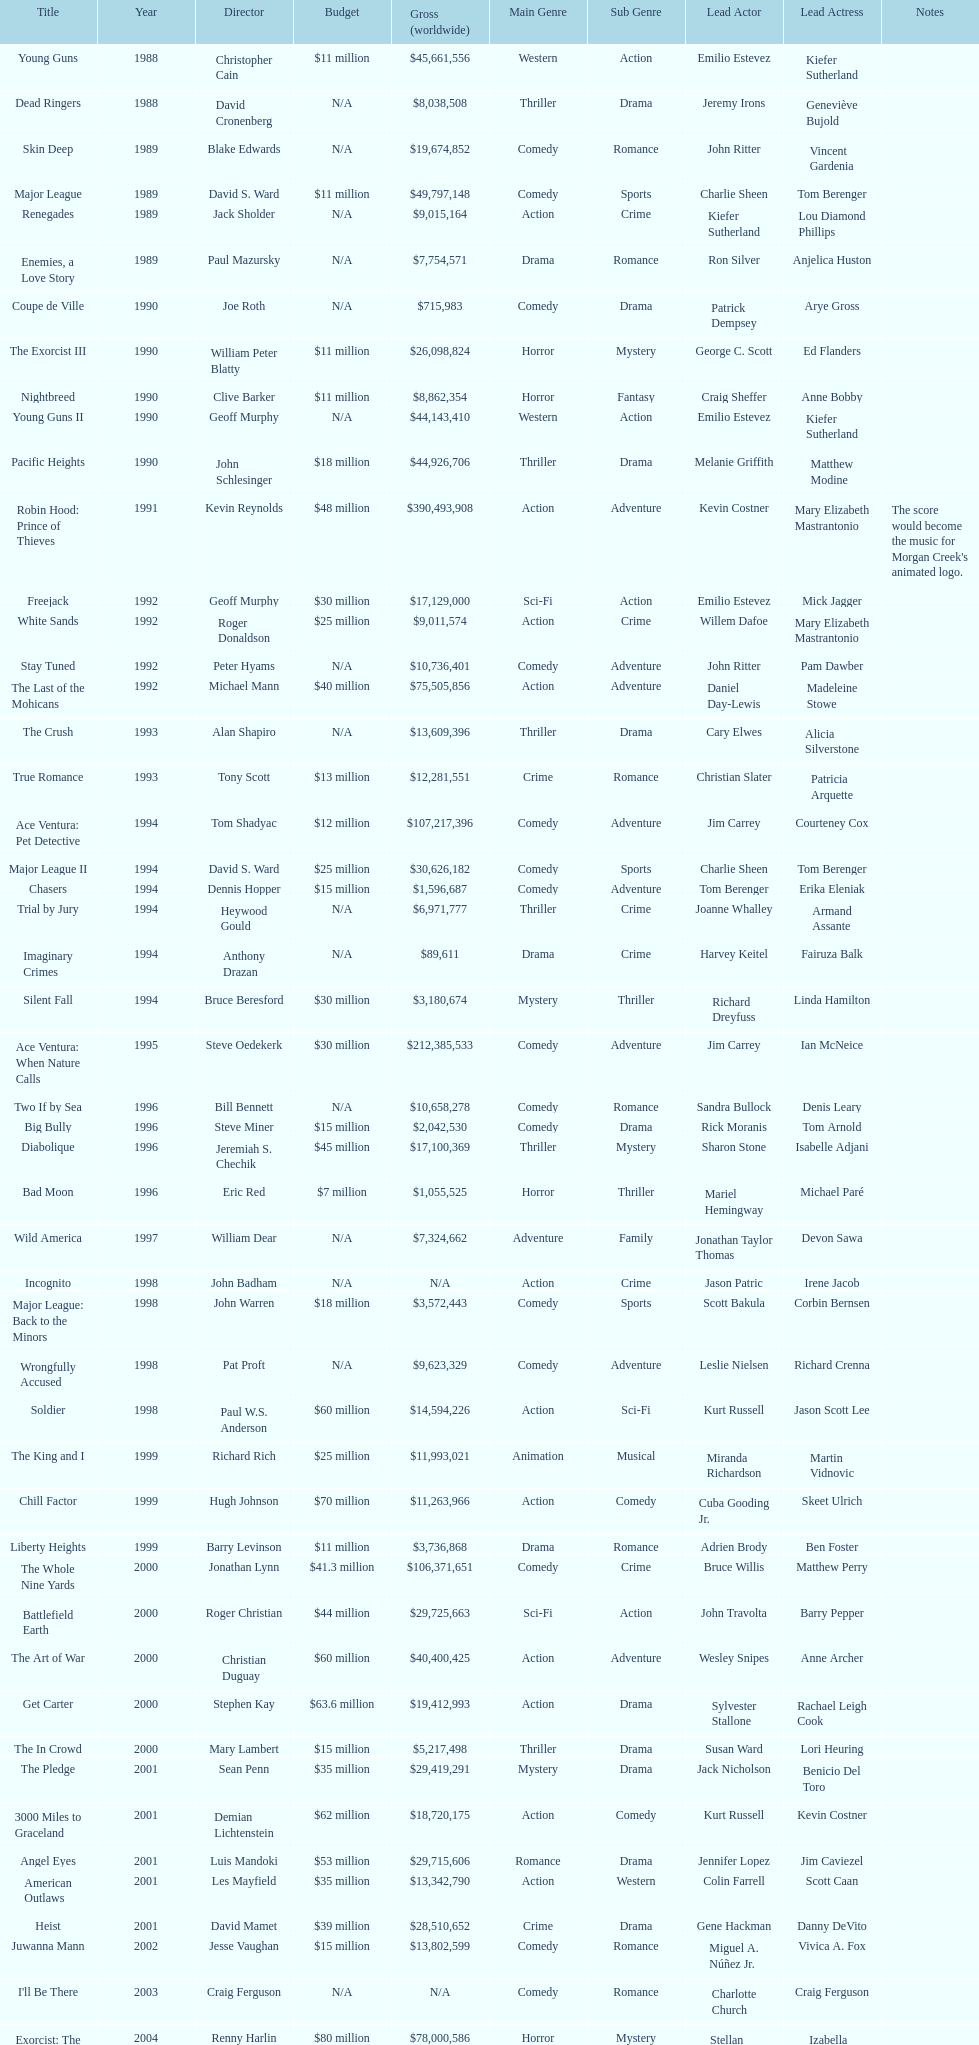Was the budget for young guns more or less than freejack's budget? Less. 